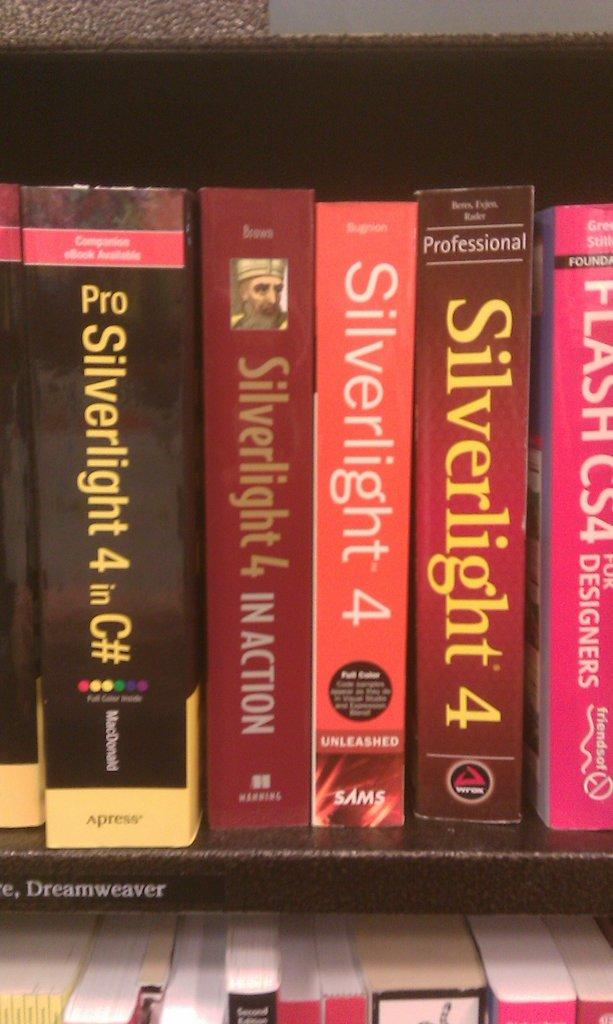What is the title to the books?
Provide a short and direct response. Silverlight. 